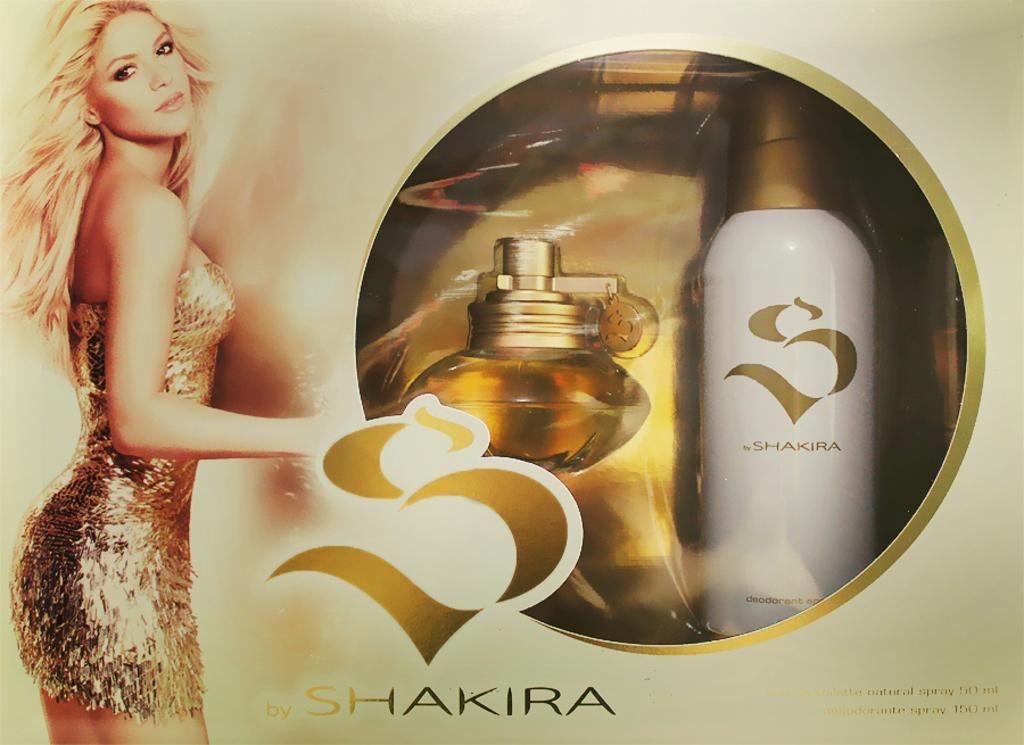Provide a one-sentence caption for the provided image. A blonde woman imposed on a package that reads, "Shakira.". 